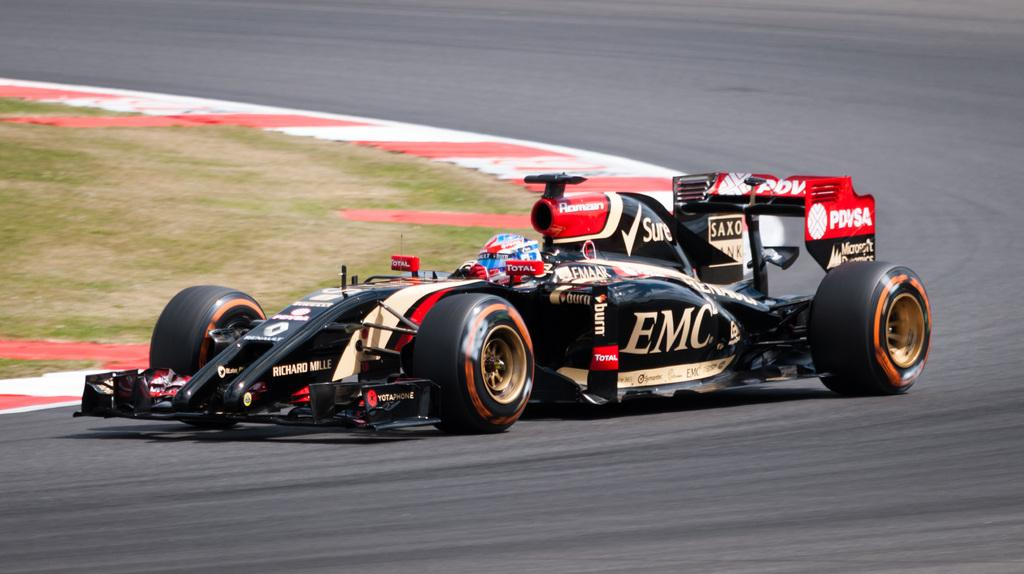What is the main subject in the center of the image? There is an image in the center of the image. What else can be seen in the image besides the central image? There is a vehicle on the road and ground visible in the image. What type of veil is draped over the car in the image? There is no car or veil present in the image. 